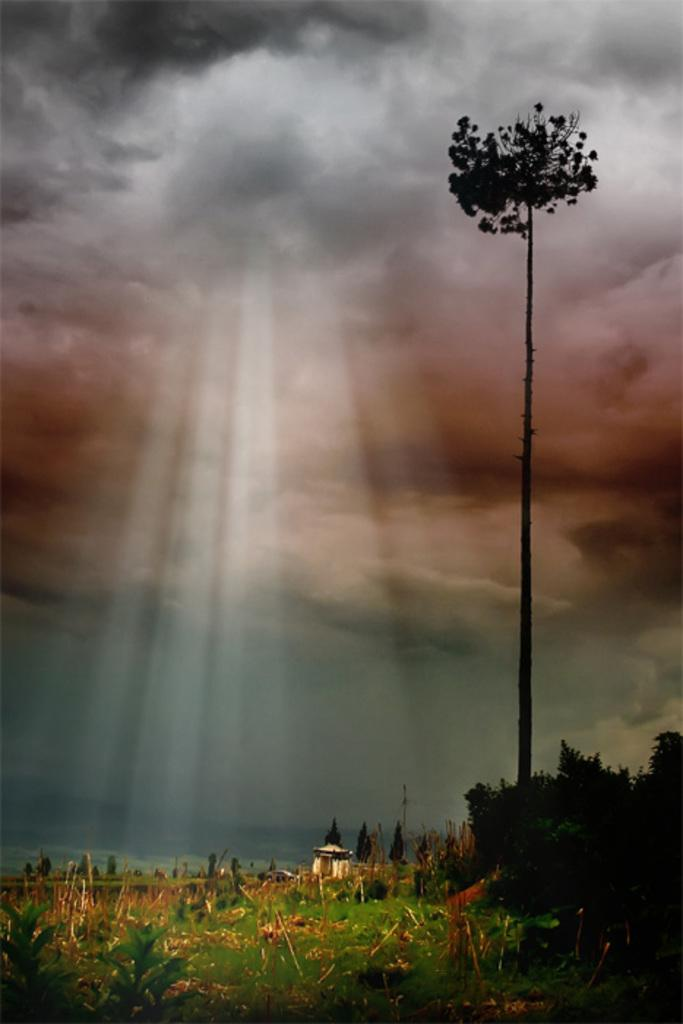What type of vegetation can be seen in the image? There are trees, plants, and grass in the image. What part of the natural environment is visible in the image? The sky is visible in the image. What type of stocking is the servant wearing in the image? There is no servant or stocking present in the image. What type of building can be seen in the image? There is no building present in the image; it features natural elements such as trees, plants, grass, and the sky. 